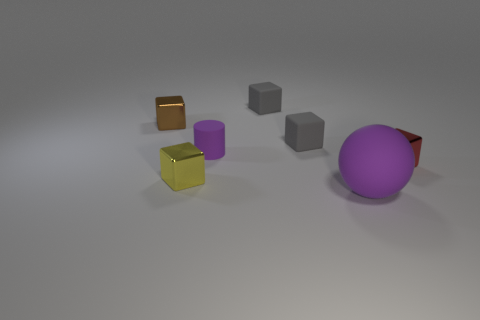Subtract all purple blocks. Subtract all purple cylinders. How many blocks are left? 5 Add 2 large green metal things. How many objects exist? 9 Subtract all blocks. How many objects are left? 2 Subtract all yellow shiny objects. Subtract all metallic blocks. How many objects are left? 3 Add 2 tiny metal blocks. How many tiny metal blocks are left? 5 Add 3 tiny purple rubber cylinders. How many tiny purple rubber cylinders exist? 4 Subtract 0 cyan blocks. How many objects are left? 7 